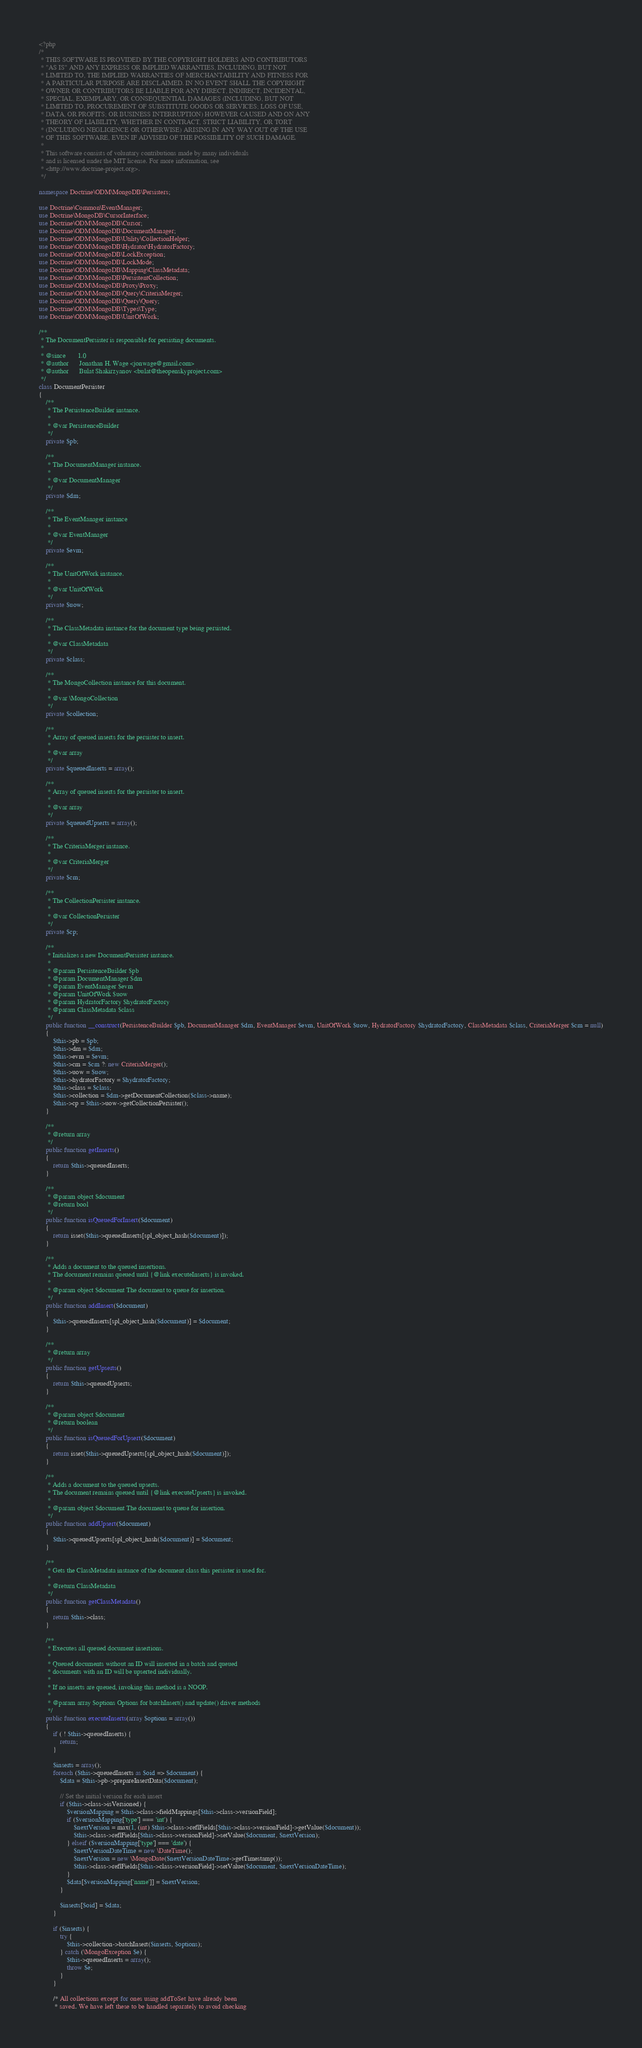Convert code to text. <code><loc_0><loc_0><loc_500><loc_500><_PHP_><?php
/*
 * THIS SOFTWARE IS PROVIDED BY THE COPYRIGHT HOLDERS AND CONTRIBUTORS
 * "AS IS" AND ANY EXPRESS OR IMPLIED WARRANTIES, INCLUDING, BUT NOT
 * LIMITED TO, THE IMPLIED WARRANTIES OF MERCHANTABILITY AND FITNESS FOR
 * A PARTICULAR PURPOSE ARE DISCLAIMED. IN NO EVENT SHALL THE COPYRIGHT
 * OWNER OR CONTRIBUTORS BE LIABLE FOR ANY DIRECT, INDIRECT, INCIDENTAL,
 * SPECIAL, EXEMPLARY, OR CONSEQUENTIAL DAMAGES (INCLUDING, BUT NOT
 * LIMITED TO, PROCUREMENT OF SUBSTITUTE GOODS OR SERVICES; LOSS OF USE,
 * DATA, OR PROFITS; OR BUSINESS INTERRUPTION) HOWEVER CAUSED AND ON ANY
 * THEORY OF LIABILITY, WHETHER IN CONTRACT, STRICT LIABILITY, OR TORT
 * (INCLUDING NEGLIGENCE OR OTHERWISE) ARISING IN ANY WAY OUT OF THE USE
 * OF THIS SOFTWARE, EVEN IF ADVISED OF THE POSSIBILITY OF SUCH DAMAGE.
 *
 * This software consists of voluntary contributions made by many individuals
 * and is licensed under the MIT license. For more information, see
 * <http://www.doctrine-project.org>.
 */

namespace Doctrine\ODM\MongoDB\Persisters;

use Doctrine\Common\EventManager;
use Doctrine\MongoDB\CursorInterface;
use Doctrine\ODM\MongoDB\Cursor;
use Doctrine\ODM\MongoDB\DocumentManager;
use Doctrine\ODM\MongoDB\Utility\CollectionHelper;
use Doctrine\ODM\MongoDB\Hydrator\HydratorFactory;
use Doctrine\ODM\MongoDB\LockException;
use Doctrine\ODM\MongoDB\LockMode;
use Doctrine\ODM\MongoDB\Mapping\ClassMetadata;
use Doctrine\ODM\MongoDB\PersistentCollection;
use Doctrine\ODM\MongoDB\Proxy\Proxy;
use Doctrine\ODM\MongoDB\Query\CriteriaMerger;
use Doctrine\ODM\MongoDB\Query\Query;
use Doctrine\ODM\MongoDB\Types\Type;
use Doctrine\ODM\MongoDB\UnitOfWork;

/**
 * The DocumentPersister is responsible for persisting documents.
 *
 * @since       1.0
 * @author      Jonathan H. Wage <jonwage@gmail.com>
 * @author      Bulat Shakirzyanov <bulat@theopenskyproject.com>
 */
class DocumentPersister
{
    /**
     * The PersistenceBuilder instance.
     *
     * @var PersistenceBuilder
     */
    private $pb;

    /**
     * The DocumentManager instance.
     *
     * @var DocumentManager
     */
    private $dm;

    /**
     * The EventManager instance
     *
     * @var EventManager
     */
    private $evm;

    /**
     * The UnitOfWork instance.
     *
     * @var UnitOfWork
     */
    private $uow;

    /**
     * The ClassMetadata instance for the document type being persisted.
     *
     * @var ClassMetadata
     */
    private $class;

    /**
     * The MongoCollection instance for this document.
     *
     * @var \MongoCollection
     */
    private $collection;

    /**
     * Array of queued inserts for the persister to insert.
     *
     * @var array
     */
    private $queuedInserts = array();

    /**
     * Array of queued inserts for the persister to insert.
     *
     * @var array
     */
    private $queuedUpserts = array();

    /**
     * The CriteriaMerger instance.
     *
     * @var CriteriaMerger
     */
    private $cm;

    /**
     * The CollectionPersister instance.
     *
     * @var CollectionPersister
     */
    private $cp;

    /**
     * Initializes a new DocumentPersister instance.
     *
     * @param PersistenceBuilder $pb
     * @param DocumentManager $dm
     * @param EventManager $evm
     * @param UnitOfWork $uow
     * @param HydratorFactory $hydratorFactory
     * @param ClassMetadata $class
     */
    public function __construct(PersistenceBuilder $pb, DocumentManager $dm, EventManager $evm, UnitOfWork $uow, HydratorFactory $hydratorFactory, ClassMetadata $class, CriteriaMerger $cm = null)
    {
        $this->pb = $pb;
        $this->dm = $dm;
        $this->evm = $evm;
        $this->cm = $cm ?: new CriteriaMerger();
        $this->uow = $uow;
        $this->hydratorFactory = $hydratorFactory;
        $this->class = $class;
        $this->collection = $dm->getDocumentCollection($class->name);
        $this->cp = $this->uow->getCollectionPersister();
    }

    /**
     * @return array
     */
    public function getInserts()
    {
        return $this->queuedInserts;
    }

    /**
     * @param object $document
     * @return bool
     */
    public function isQueuedForInsert($document)
    {
        return isset($this->queuedInserts[spl_object_hash($document)]);
    }

    /**
     * Adds a document to the queued insertions.
     * The document remains queued until {@link executeInserts} is invoked.
     *
     * @param object $document The document to queue for insertion.
     */
    public function addInsert($document)
    {
        $this->queuedInserts[spl_object_hash($document)] = $document;
    }

    /**
     * @return array
     */
    public function getUpserts()
    {
        return $this->queuedUpserts;
    }

    /**
     * @param object $document
     * @return boolean
     */
    public function isQueuedForUpsert($document)
    {
        return isset($this->queuedUpserts[spl_object_hash($document)]);
    }

    /**
     * Adds a document to the queued upserts.
     * The document remains queued until {@link executeUpserts} is invoked.
     *
     * @param object $document The document to queue for insertion.
     */
    public function addUpsert($document)
    {
        $this->queuedUpserts[spl_object_hash($document)] = $document;
    }

    /**
     * Gets the ClassMetadata instance of the document class this persister is used for.
     *
     * @return ClassMetadata
     */
    public function getClassMetadata()
    {
        return $this->class;
    }

    /**
     * Executes all queued document insertions.
     *
     * Queued documents without an ID will inserted in a batch and queued
     * documents with an ID will be upserted individually.
     *
     * If no inserts are queued, invoking this method is a NOOP.
     *
     * @param array $options Options for batchInsert() and update() driver methods
     */
    public function executeInserts(array $options = array())
    {
        if ( ! $this->queuedInserts) {
            return;
        }

        $inserts = array();
        foreach ($this->queuedInserts as $oid => $document) {
            $data = $this->pb->prepareInsertData($document);

            // Set the initial version for each insert
            if ($this->class->isVersioned) {
                $versionMapping = $this->class->fieldMappings[$this->class->versionField];
                if ($versionMapping['type'] === 'int') {
                    $nextVersion = max(1, (int) $this->class->reflFields[$this->class->versionField]->getValue($document));
                    $this->class->reflFields[$this->class->versionField]->setValue($document, $nextVersion);
                } elseif ($versionMapping['type'] === 'date') {
                    $nextVersionDateTime = new \DateTime();
                    $nextVersion = new \MongoDate($nextVersionDateTime->getTimestamp());
                    $this->class->reflFields[$this->class->versionField]->setValue($document, $nextVersionDateTime);
                }
                $data[$versionMapping['name']] = $nextVersion;
            }

            $inserts[$oid] = $data;
        }

        if ($inserts) {
            try {
                $this->collection->batchInsert($inserts, $options);
            } catch (\MongoException $e) {
                $this->queuedInserts = array();
                throw $e;
            }
        }

        /* All collections except for ones using addToSet have already been
         * saved. We have left these to be handled separately to avoid checking</code> 